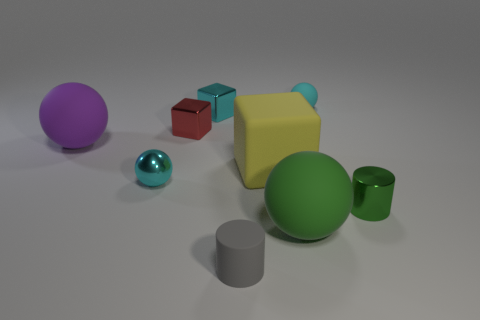What material is the green sphere that is in front of the tiny metallic sphere?
Your answer should be compact. Rubber. What number of tiny things are either matte blocks or cyan balls?
Your answer should be compact. 2. There is a big ball that is the same color as the small shiny cylinder; what material is it?
Your answer should be very brief. Rubber. Is there another small object that has the same material as the small red thing?
Provide a succinct answer. Yes. Does the cyan sphere that is behind the purple matte object have the same size as the purple thing?
Provide a succinct answer. No. Is there a small red metallic object to the right of the tiny ball behind the cyan metallic thing in front of the big matte cube?
Your answer should be very brief. No. How many shiny things are either small red cubes or small green things?
Your answer should be very brief. 2. How many other things are there of the same shape as the large yellow matte thing?
Your answer should be compact. 2. Is the number of tiny gray rubber cylinders greater than the number of tiny brown objects?
Make the answer very short. Yes. How big is the rubber ball in front of the tiny metal thing that is in front of the small sphere in front of the large yellow matte block?
Provide a short and direct response. Large. 